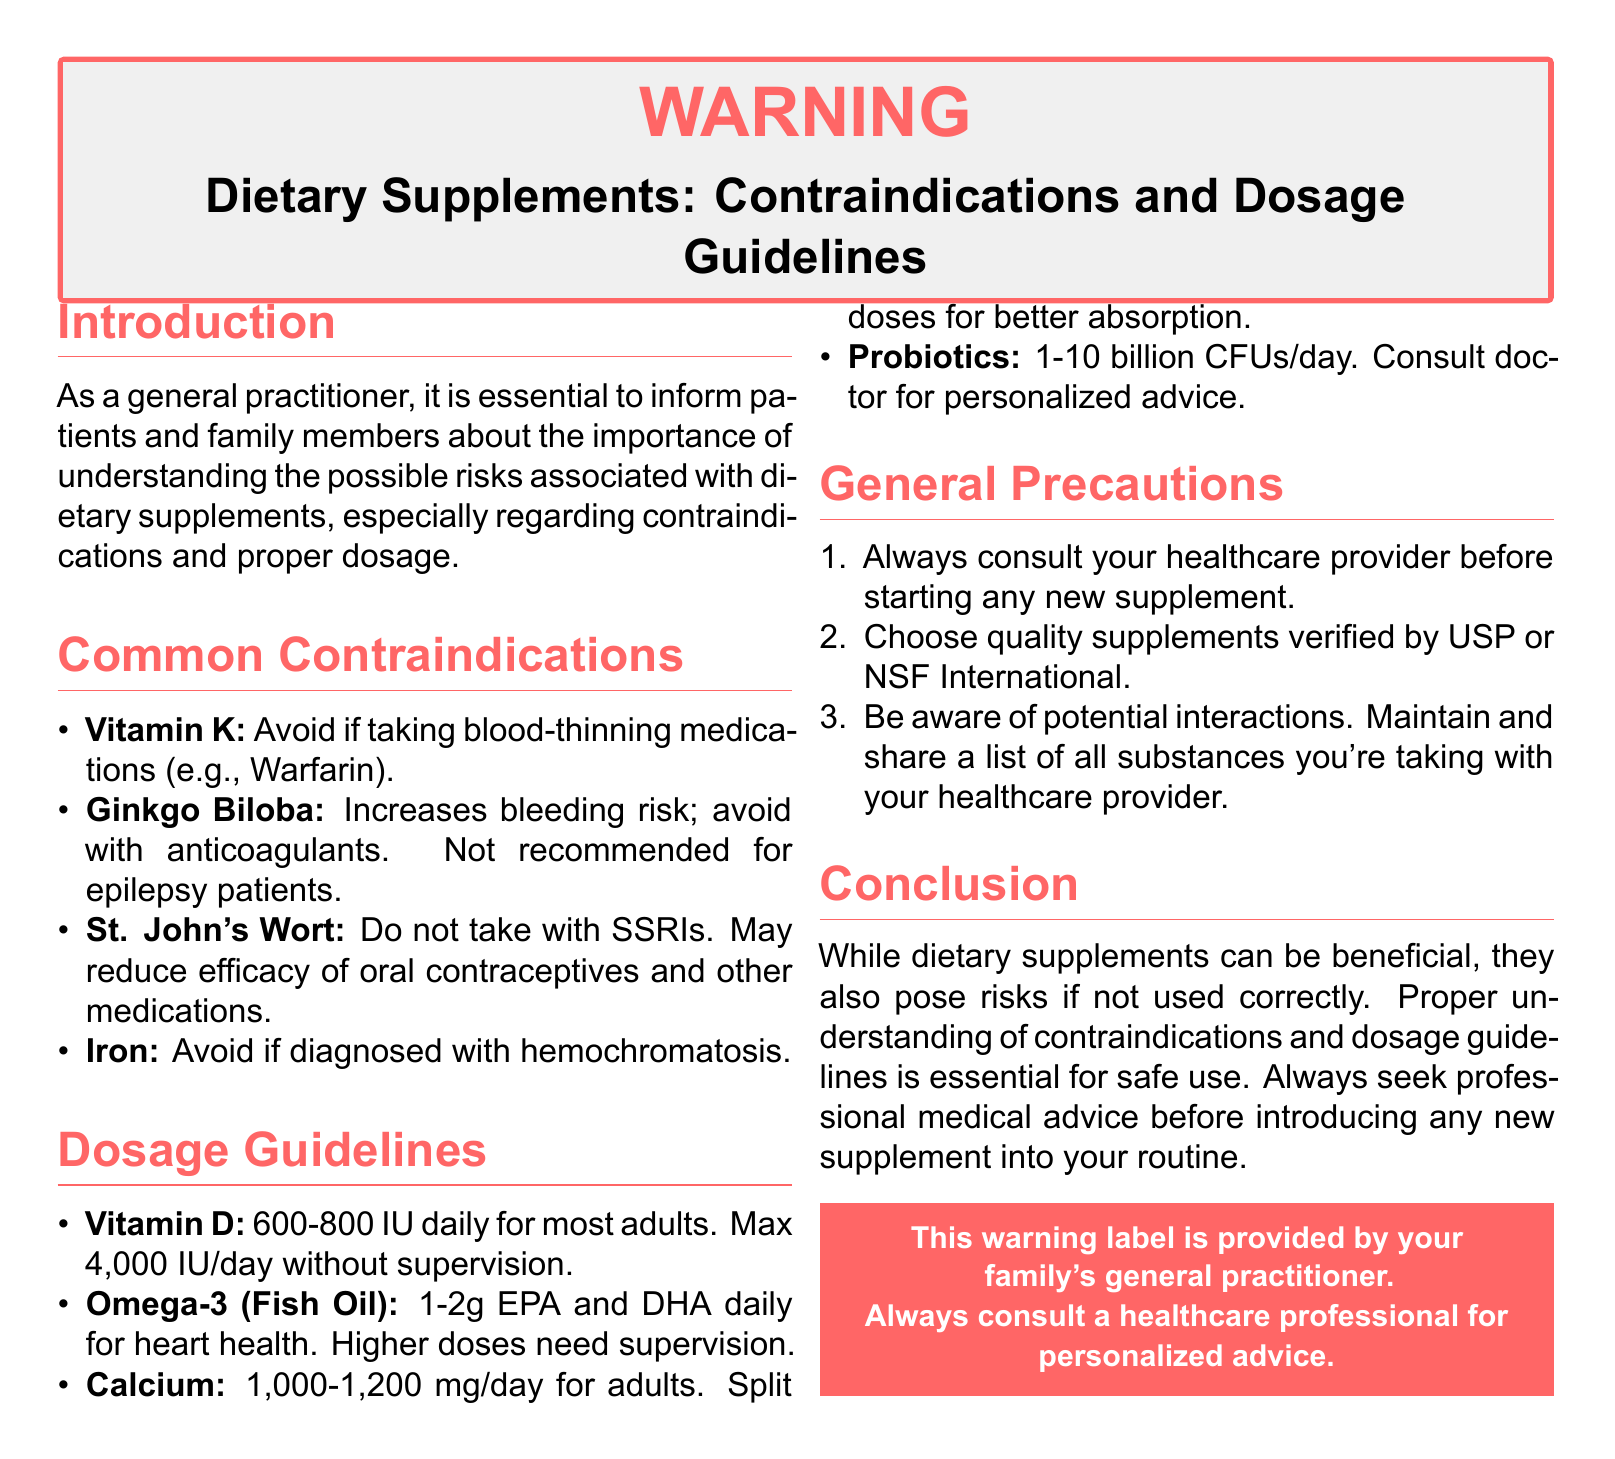What is the maximum daily dosage of Vitamin D without supervision? The document specifies the max dosage for Vitamin D without supervision, which is 4,000 IU/day.
Answer: 4,000 IU/day What should be avoided if taking blood-thinning medications? The document lists Vitamin K as something to avoid when taking blood-thinning medications such as Warfarin.
Answer: Vitamin K How much Omega-3 is recommended for heart health? According to the dosage guidelines, 1-2g of EPA and DHA is recommended daily for heart health.
Answer: 1-2g Which supplement should be avoided if diagnosed with hemochromatosis? The document indicates that Iron should be avoided if diagnosed with hemochromatosis.
Answer: Iron What is the general advice before starting any new supplement? It emphasizes to always consult your healthcare provider before starting any new supplement.
Answer: Consult your healthcare provider What is the recommended daily intake of Calcium for adults? The document mentions that the recommended daily intake of Calcium for adults is 1,000-1,200 mg/day.
Answer: 1,000-1,200 mg/day What does St. John's Wort interact negatively with? The document states that St. John's Wort should not be taken with SSRIs.
Answer: SSRIs What should be maintained and shared with your healthcare provider? The document advises to maintain and share a list of all substances you are taking with your healthcare provider.
Answer: A list of all substances What is the main focus of this warning label? The main focus is to inform about the importance of understanding the possible risks associated with dietary supplements.
Answer: Understanding possible risks 